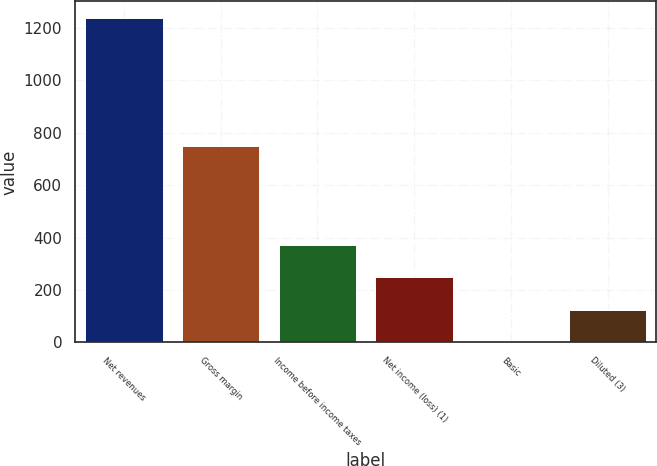Convert chart to OTSL. <chart><loc_0><loc_0><loc_500><loc_500><bar_chart><fcel>Net revenues<fcel>Gross margin<fcel>Income before income taxes<fcel>Net income (loss) (1)<fcel>Basic<fcel>Diluted (3)<nl><fcel>1239.5<fcel>751.2<fcel>372.13<fcel>248.22<fcel>0.4<fcel>124.31<nl></chart> 